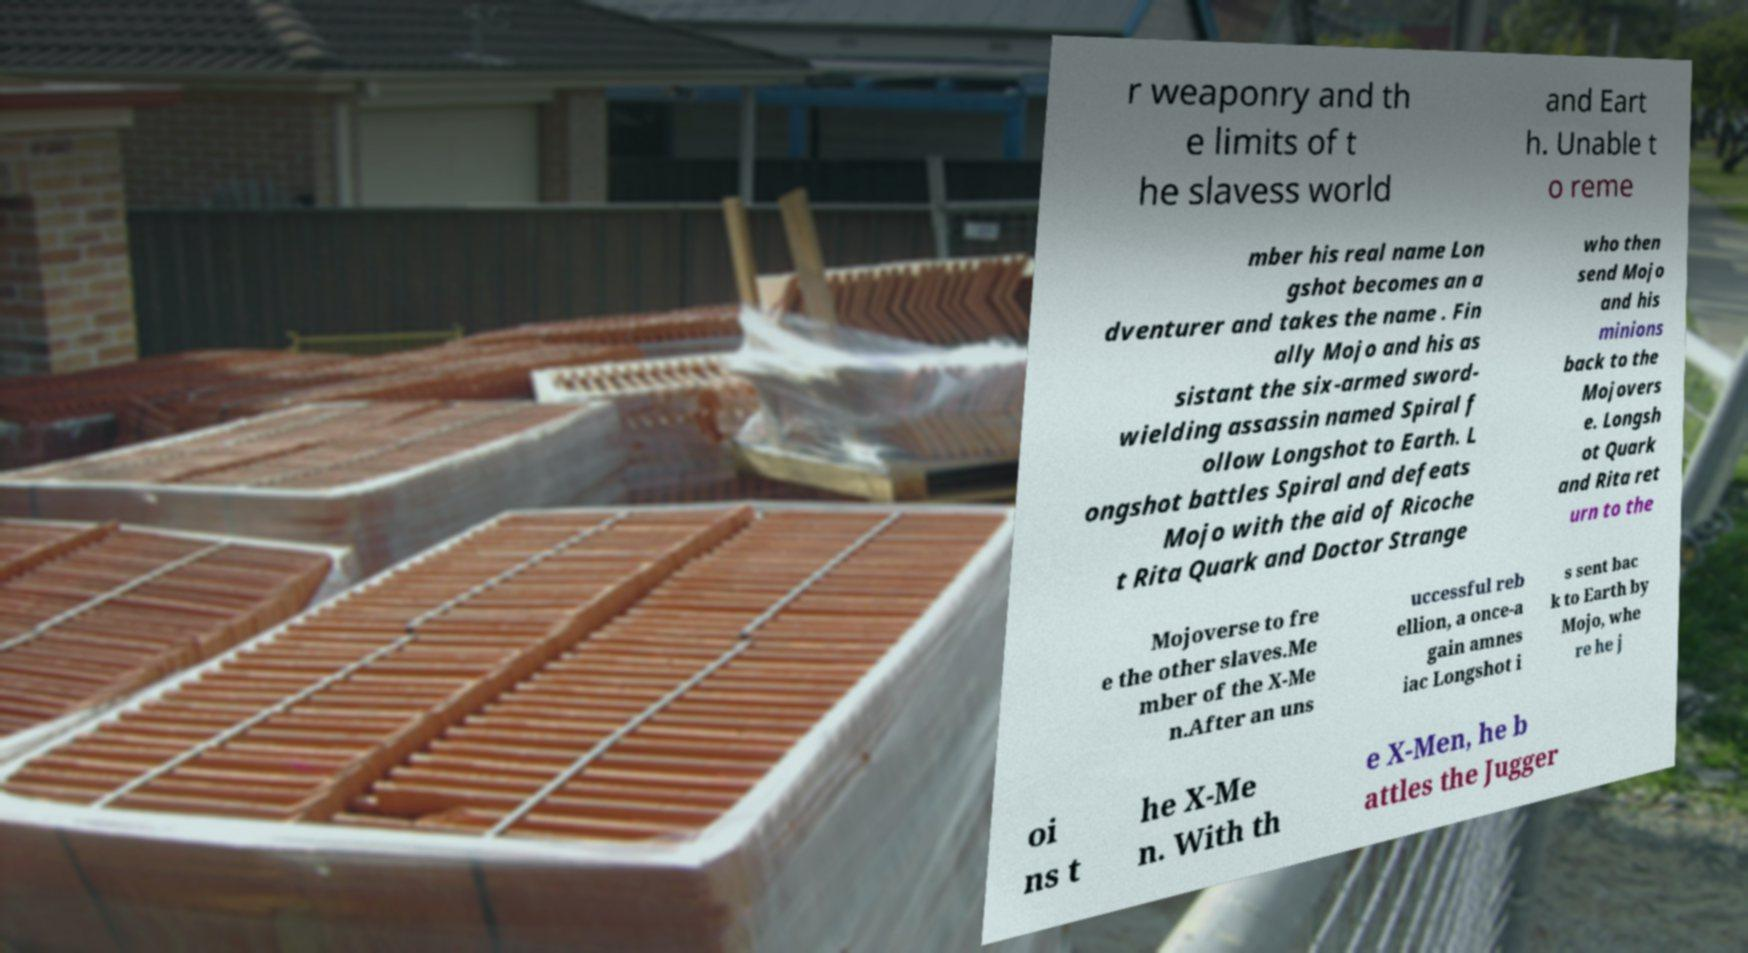I need the written content from this picture converted into text. Can you do that? r weaponry and th e limits of t he slavess world and Eart h. Unable t o reme mber his real name Lon gshot becomes an a dventurer and takes the name . Fin ally Mojo and his as sistant the six-armed sword- wielding assassin named Spiral f ollow Longshot to Earth. L ongshot battles Spiral and defeats Mojo with the aid of Ricoche t Rita Quark and Doctor Strange who then send Mojo and his minions back to the Mojovers e. Longsh ot Quark and Rita ret urn to the Mojoverse to fre e the other slaves.Me mber of the X-Me n.After an uns uccessful reb ellion, a once-a gain amnes iac Longshot i s sent bac k to Earth by Mojo, whe re he j oi ns t he X-Me n. With th e X-Men, he b attles the Jugger 